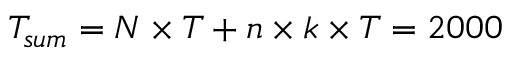Convert formula to latex. <formula><loc_0><loc_0><loc_500><loc_500>T _ { s u m } = N \times T + n \times k \times T = 2 0 0 0</formula> 